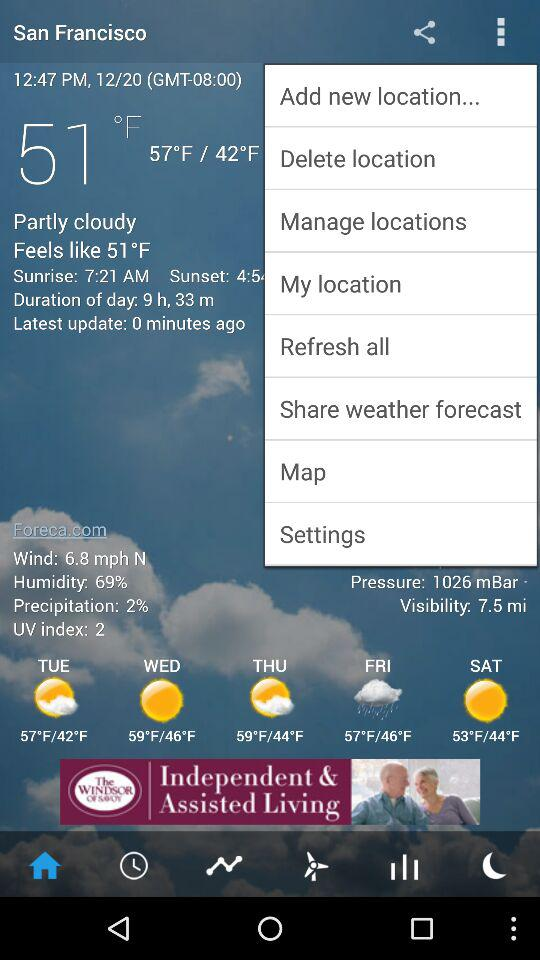What is the temperature on 12/20? The temperature is 51 °F. 